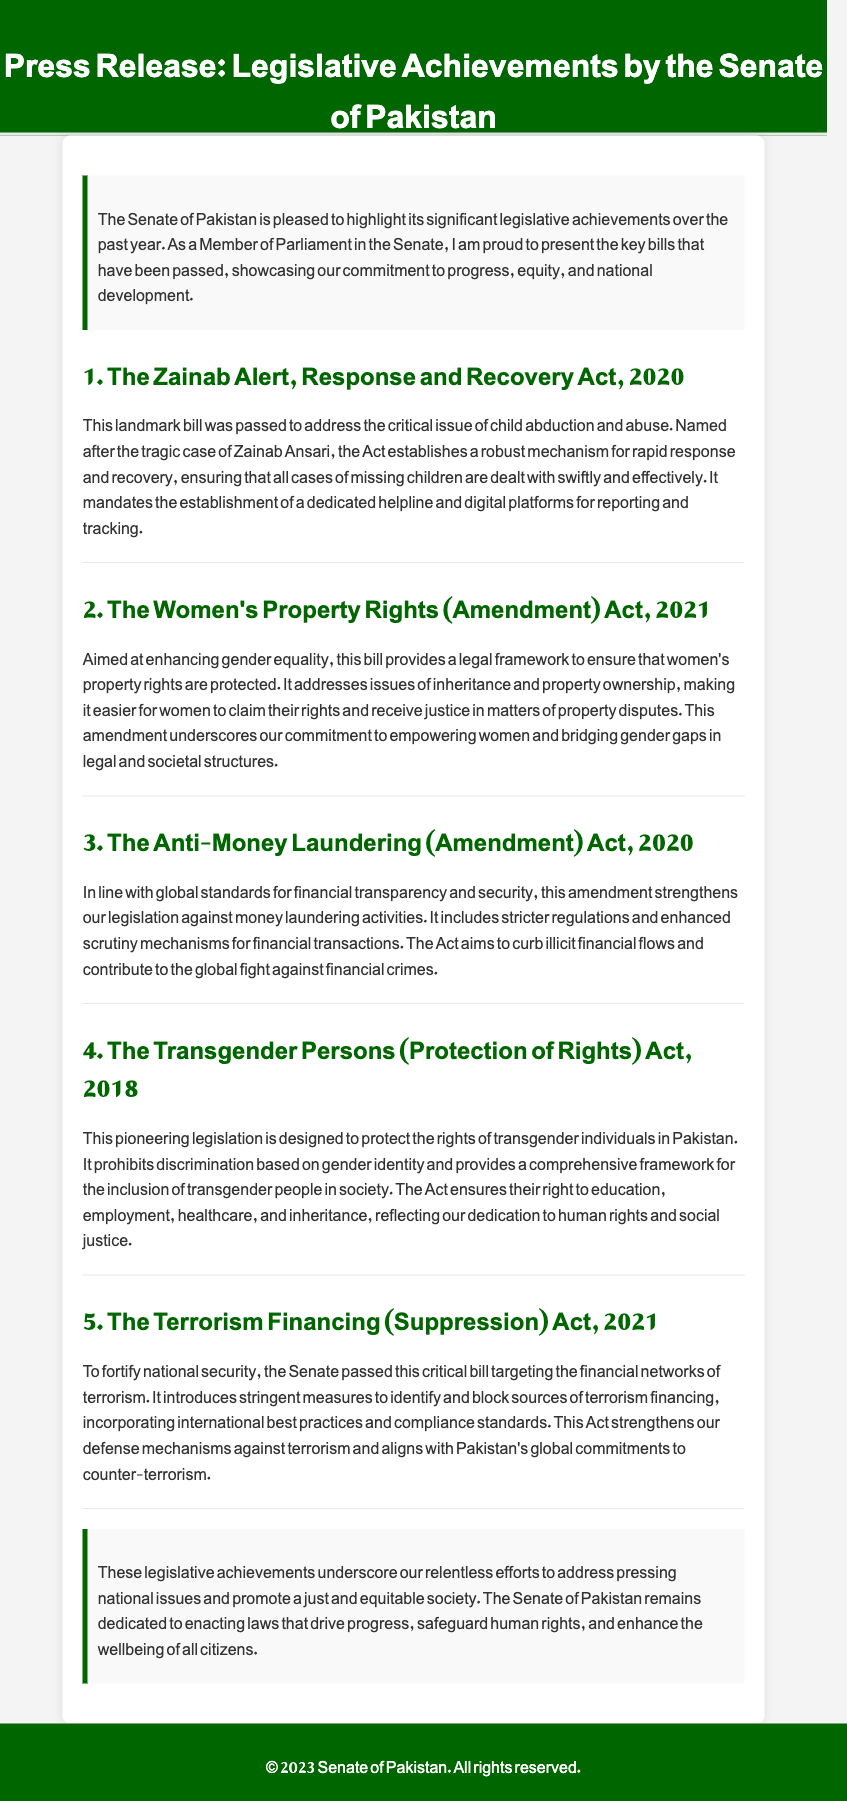What is the title of the press release? The title is specified in the header of the document, which announces the legislative achievements by the Senate of Pakistan.
Answer: Press Release: Legislative Achievements by the Senate of Pakistan How many key bills are highlighted in the document? The document lists five significant bills that have been passed, as indicated by the headings for each.
Answer: 5 What is the purpose of the Zainab Alert, Response and Recovery Act, 2020? The purpose is outlined in the description of the act, focusing on addressing the critical issue of child abduction and abuse.
Answer: Child abduction and abuse What year was the Anti-Money Laundering (Amendment) Act passed? The year is mentioned in the section heading for the act, reflecting when the legislation was enacted.
Answer: 2020 Which act protects the rights of transgender individuals? The act is specifically mentioned in one of the sections, focusing on the protection of rights for a particular community.
Answer: The Transgender Persons (Protection of Rights) Act, 2018 What key issue does the Women's Property Rights (Amendment) Act, 2021 address? The document states that this amendment addresses issues of inheritance and property ownership for women.
Answer: Gender equality Which act strengthens measures against terrorism financing? The document specifies this information in the description of the relevant legislation aimed at national security.
Answer: The Terrorism Financing (Suppression) Act, 2021 What element of society does the Senate of Pakistan aim to empower through its legislative achievements? The document mentions that the legislation aims to enhance various rights and societal participation.
Answer: Women and transgender individuals What is the overall goal of the legislative achievements described in the document? The document concludes with a statement of the goals intended through the passed legislation, mentioning social justice and equity.
Answer: Progress, equity, and national development 